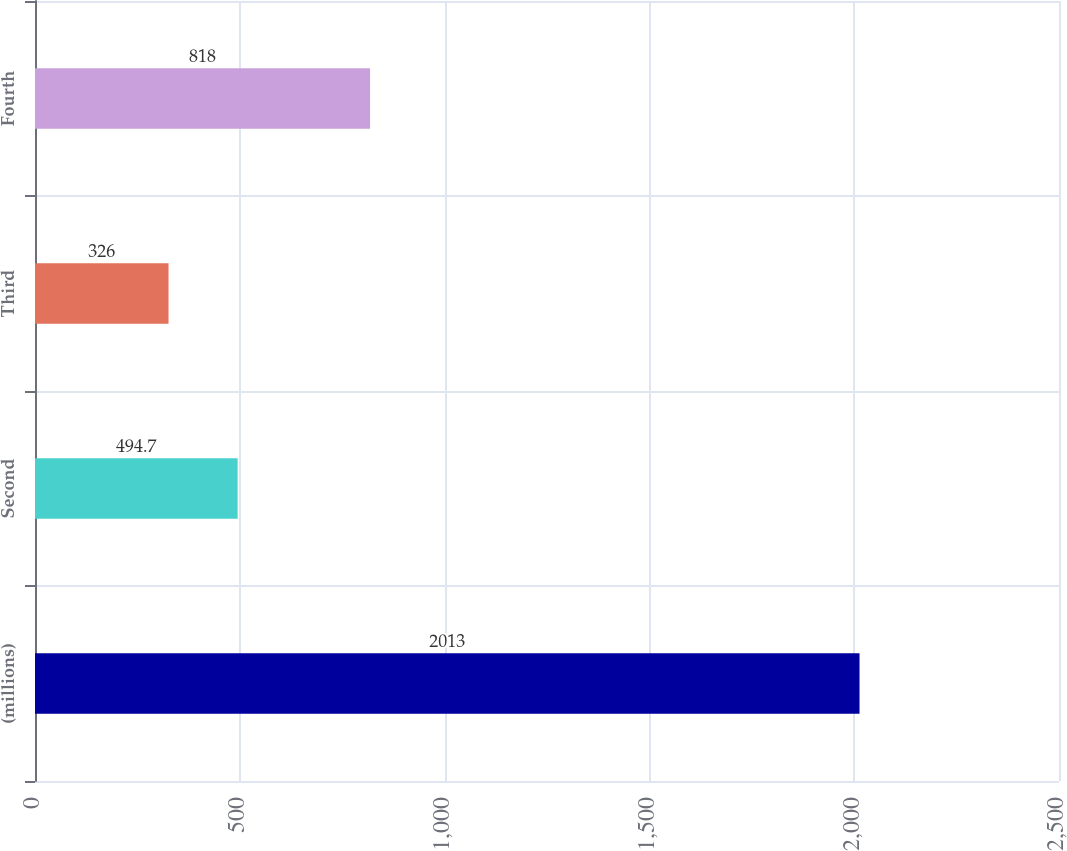<chart> <loc_0><loc_0><loc_500><loc_500><bar_chart><fcel>(millions)<fcel>Second<fcel>Third<fcel>Fourth<nl><fcel>2013<fcel>494.7<fcel>326<fcel>818<nl></chart> 